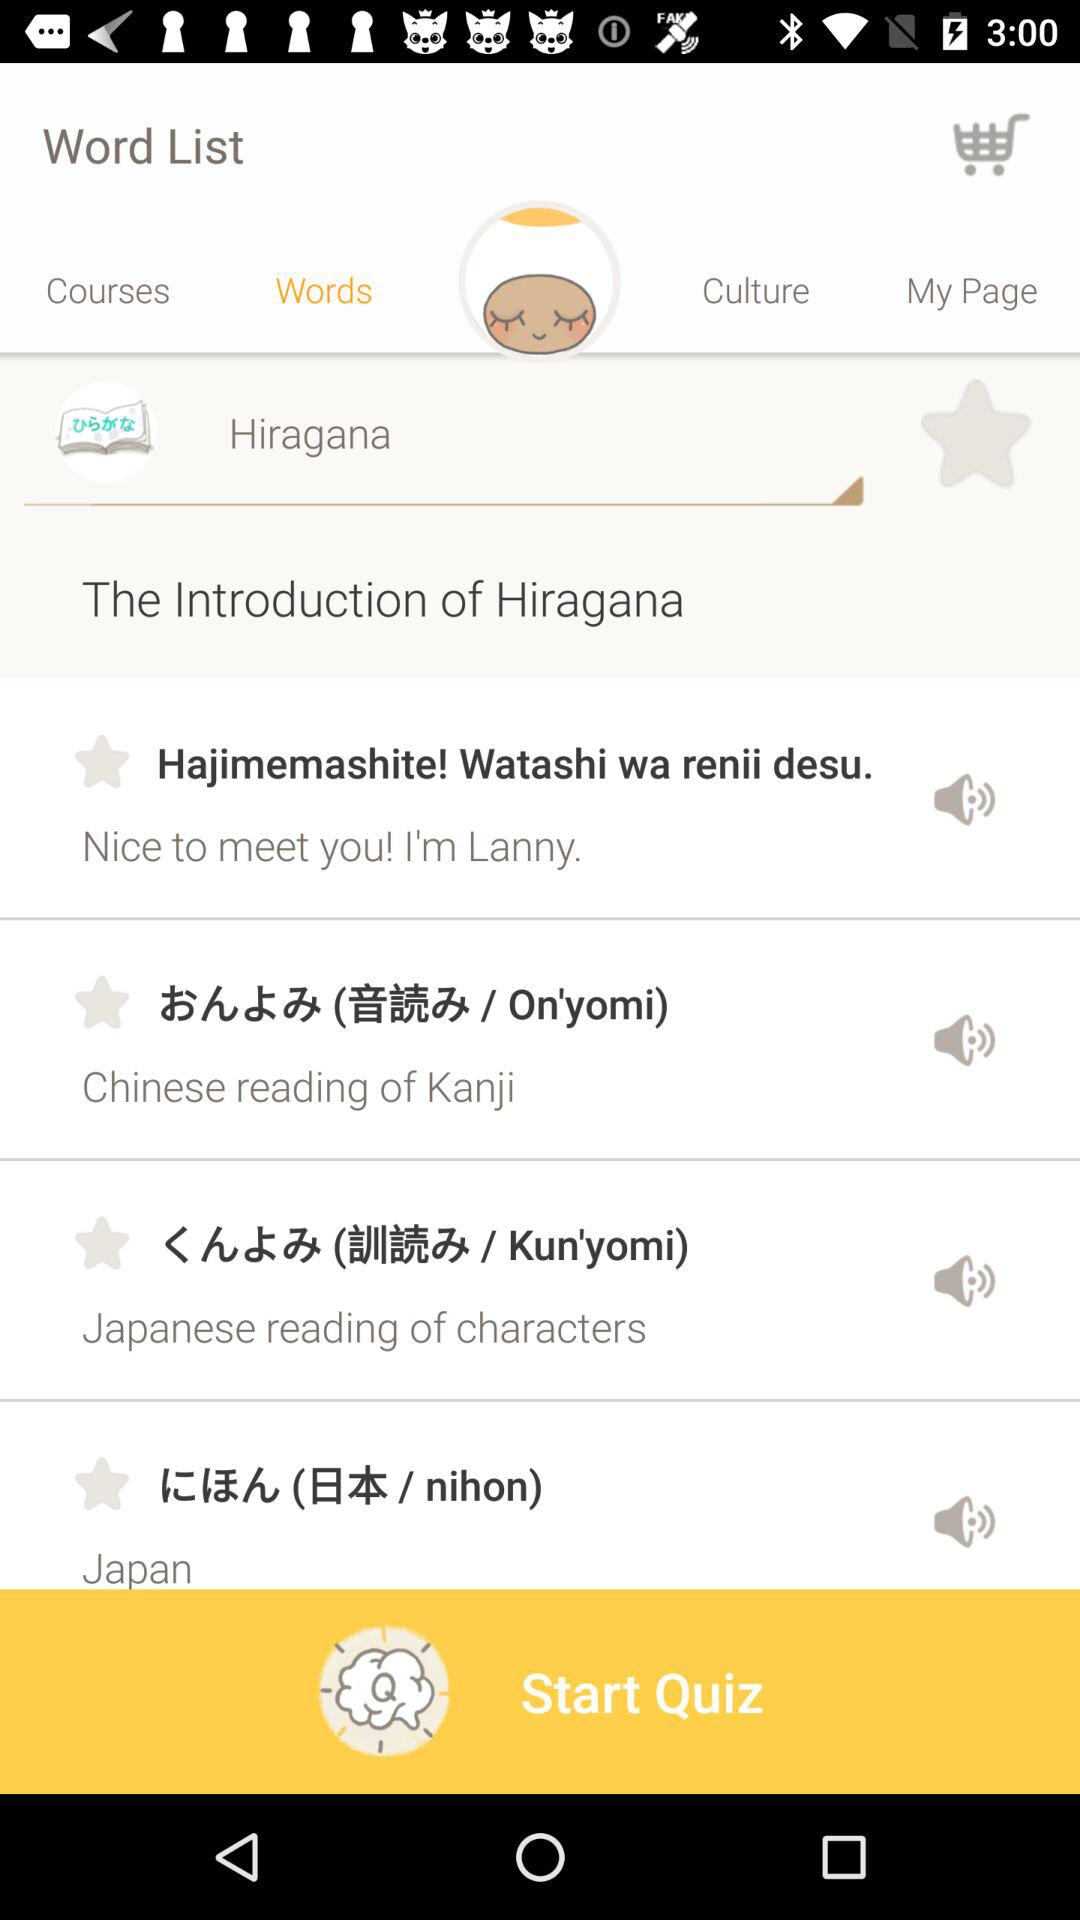How many items have a star?
Answer the question using a single word or phrase. 4 